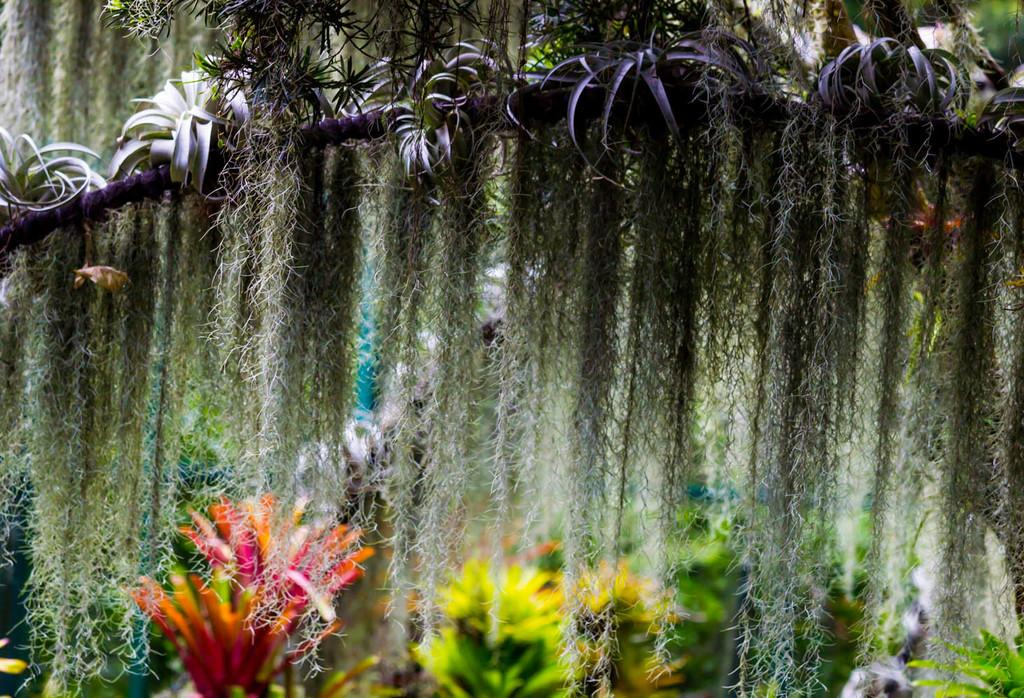What types of living organisms are present in the image? The image contains many plants. What parts of the plants can be seen in the image? The image contains stems. How would you describe the overall appearance of the image? The image is colorful. What type of tooth is visible in the image? There is no tooth present in the image; it features many plants and stems. What organization is responsible for the arrangement of the plants in the image? There is no organization responsible for the arrangement of the plants in the image; it is a natural scene. 